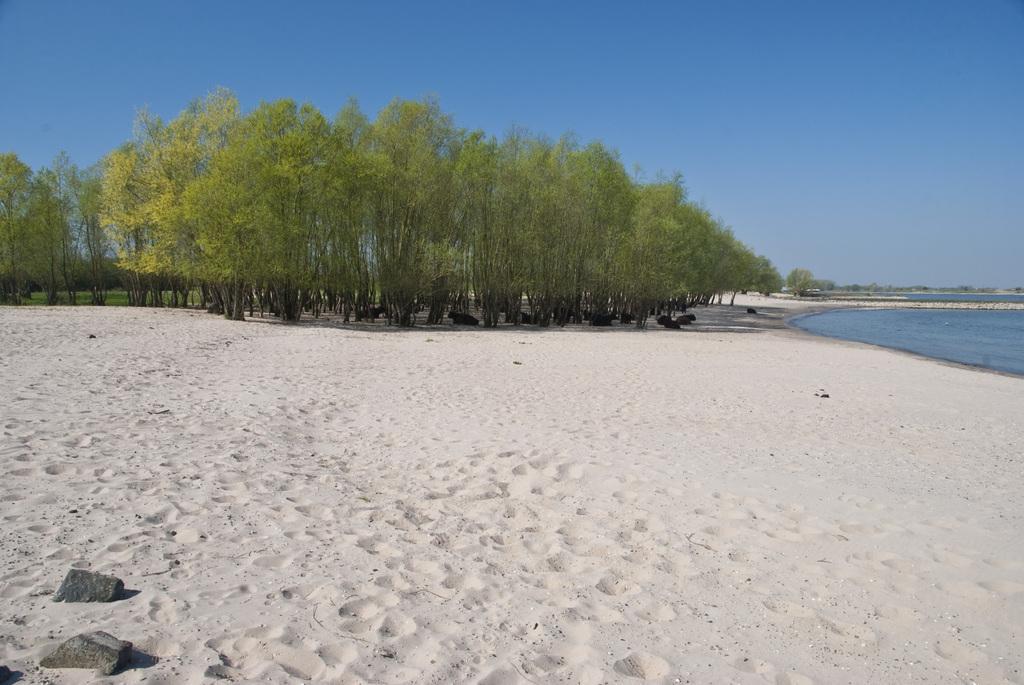Can you describe this image briefly? In this picture I can see trees on the ground. On the right side, I can see water. In the background, I can see the sky. 